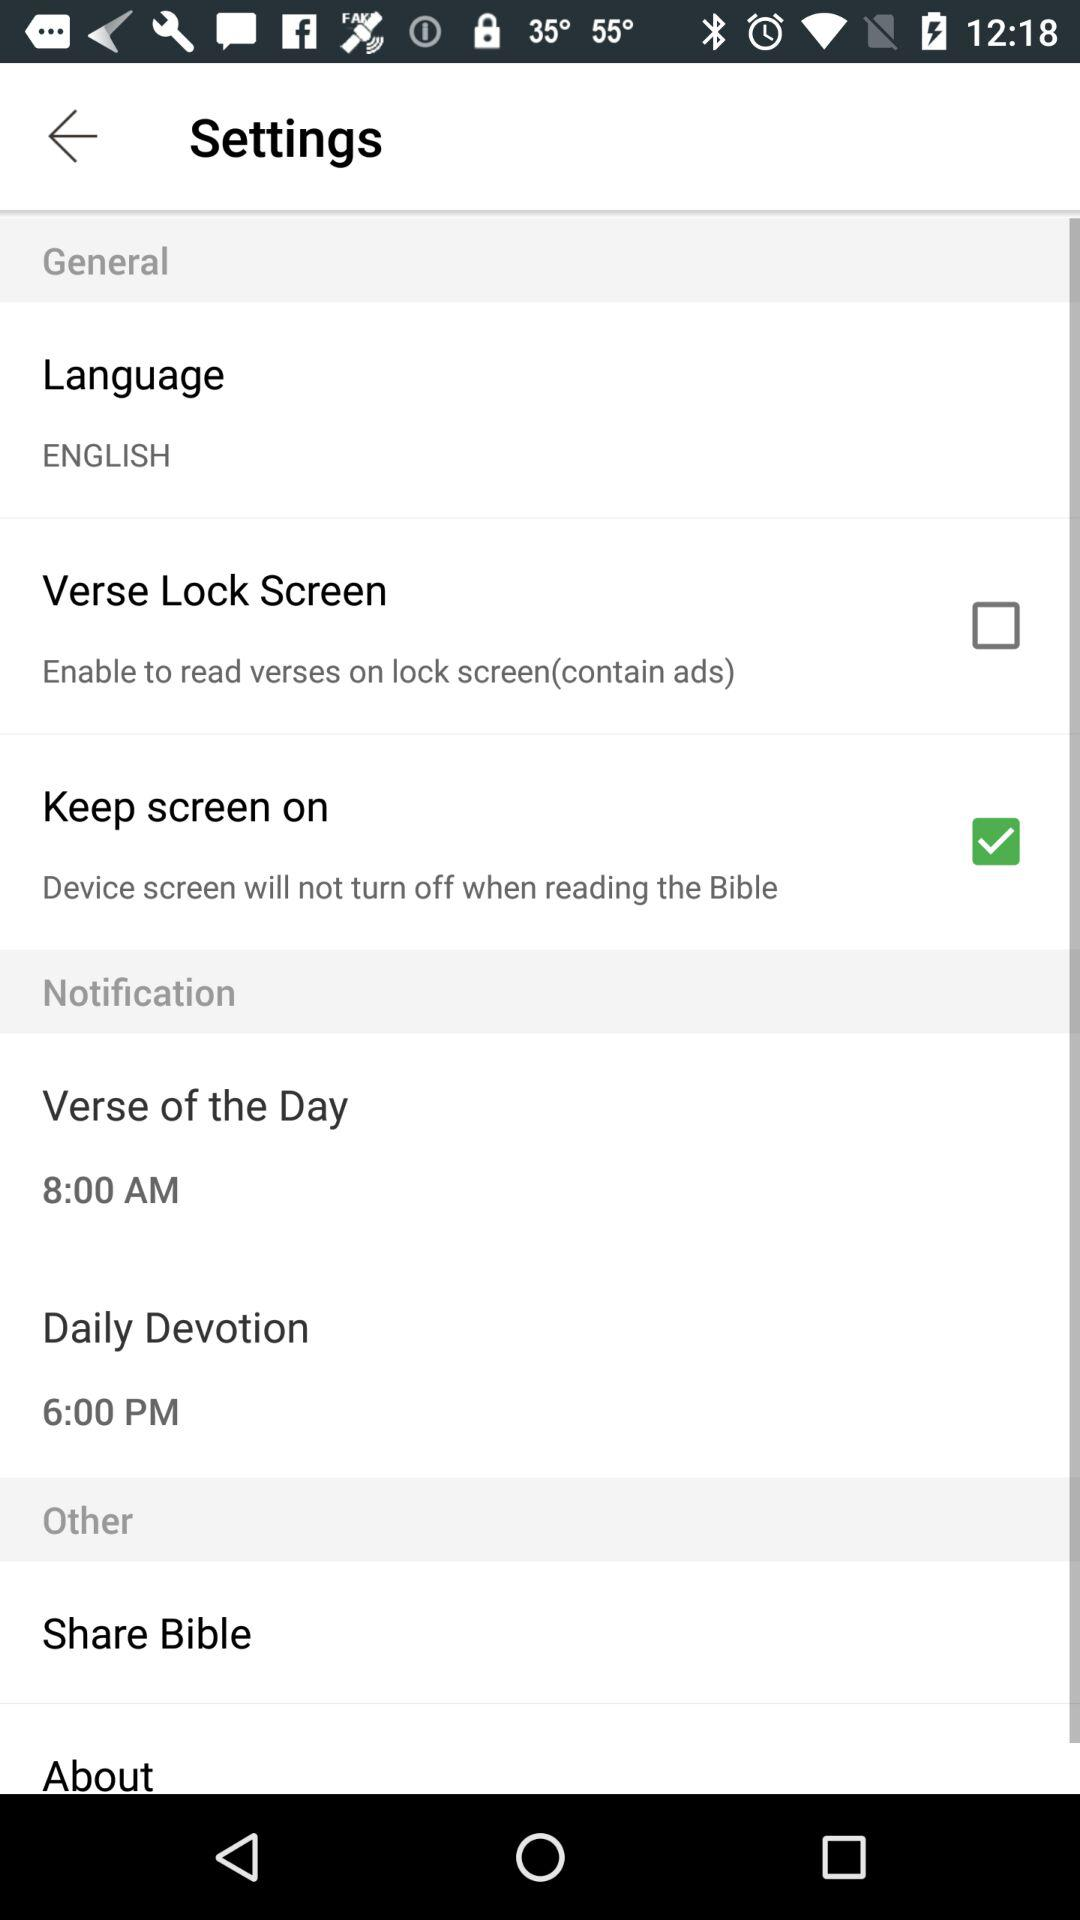What is the status of "Keep screen on"? The status of "Keep screen on" is "on". 